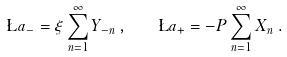Convert formula to latex. <formula><loc_0><loc_0><loc_500><loc_500>\L a _ { - } = \xi \sum _ { n = 1 } ^ { \infty } Y _ { - n } \, , \quad \L a _ { + } = - P \sum _ { n = 1 } ^ { \infty } X _ { n } \, .</formula> 